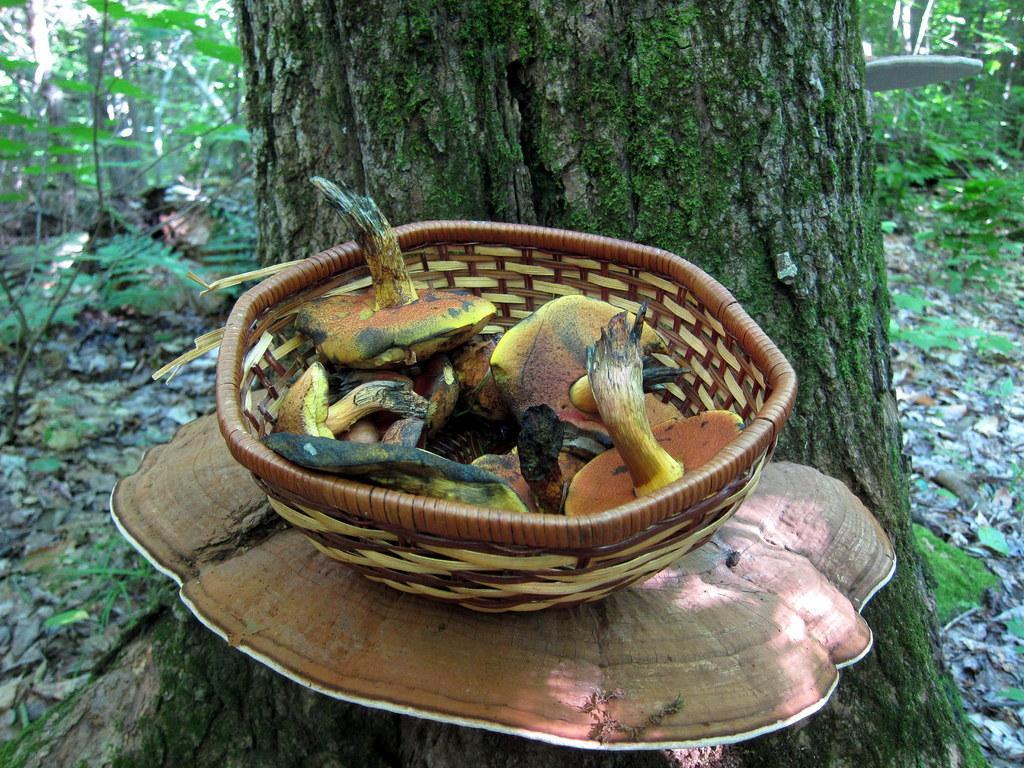Can you describe this image briefly? In this picture, we see a basket containing the mushrooms is placed on the brown color thing. Behind that, we see the stem of the tree. At the bottom, we see the dry leaves and twigs. There are trees in the background. 